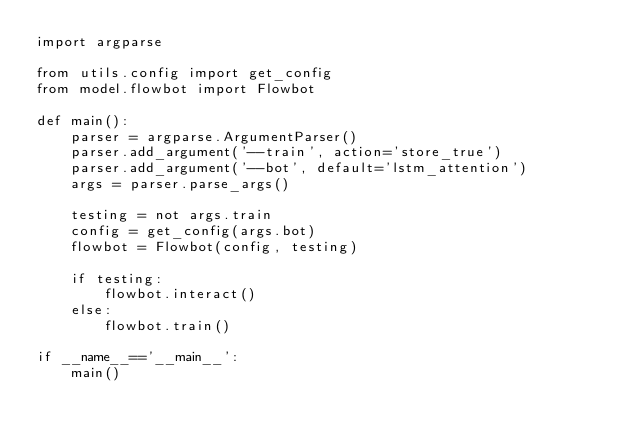Convert code to text. <code><loc_0><loc_0><loc_500><loc_500><_Python_>import argparse

from utils.config import get_config
from model.flowbot import Flowbot

def main():
    parser = argparse.ArgumentParser()
    parser.add_argument('--train', action='store_true')
    parser.add_argument('--bot', default='lstm_attention')
    args = parser.parse_args()

    testing = not args.train
    config = get_config(args.bot)
    flowbot = Flowbot(config, testing)

    if testing:
        flowbot.interact()
    else:
        flowbot.train()

if __name__=='__main__':
    main()
</code> 